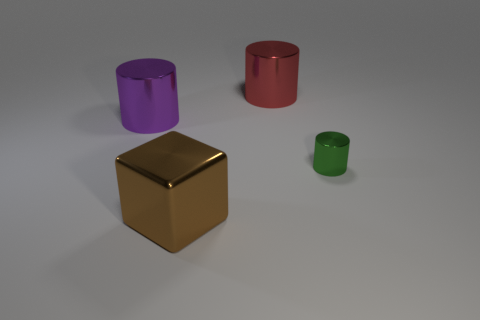Add 1 blue metallic cylinders. How many objects exist? 5 Subtract all green cylinders. How many cylinders are left? 2 Subtract all red metallic cylinders. How many cylinders are left? 2 Subtract 0 brown spheres. How many objects are left? 4 Subtract all blocks. How many objects are left? 3 Subtract 1 cubes. How many cubes are left? 0 Subtract all gray cylinders. Subtract all red blocks. How many cylinders are left? 3 Subtract all purple balls. How many purple cylinders are left? 1 Subtract all purple cylinders. Subtract all big brown cubes. How many objects are left? 2 Add 2 big purple objects. How many big purple objects are left? 3 